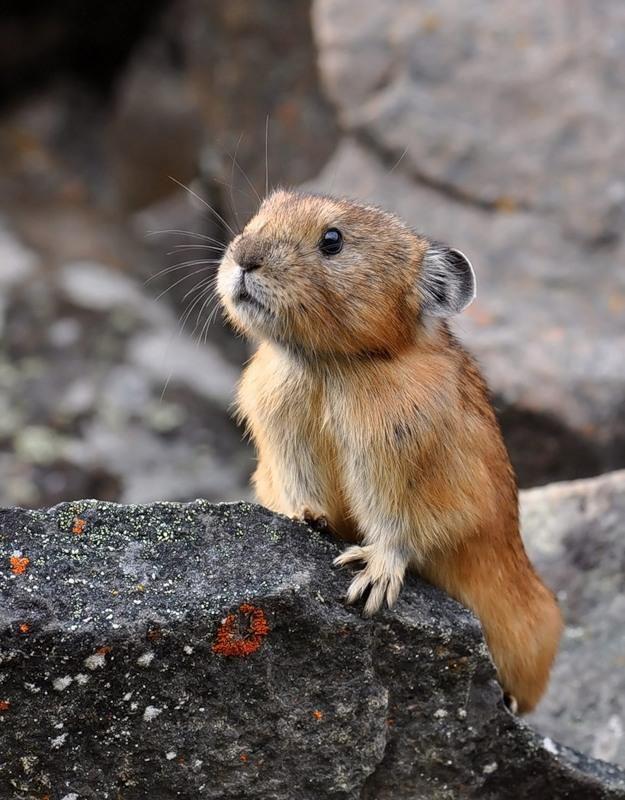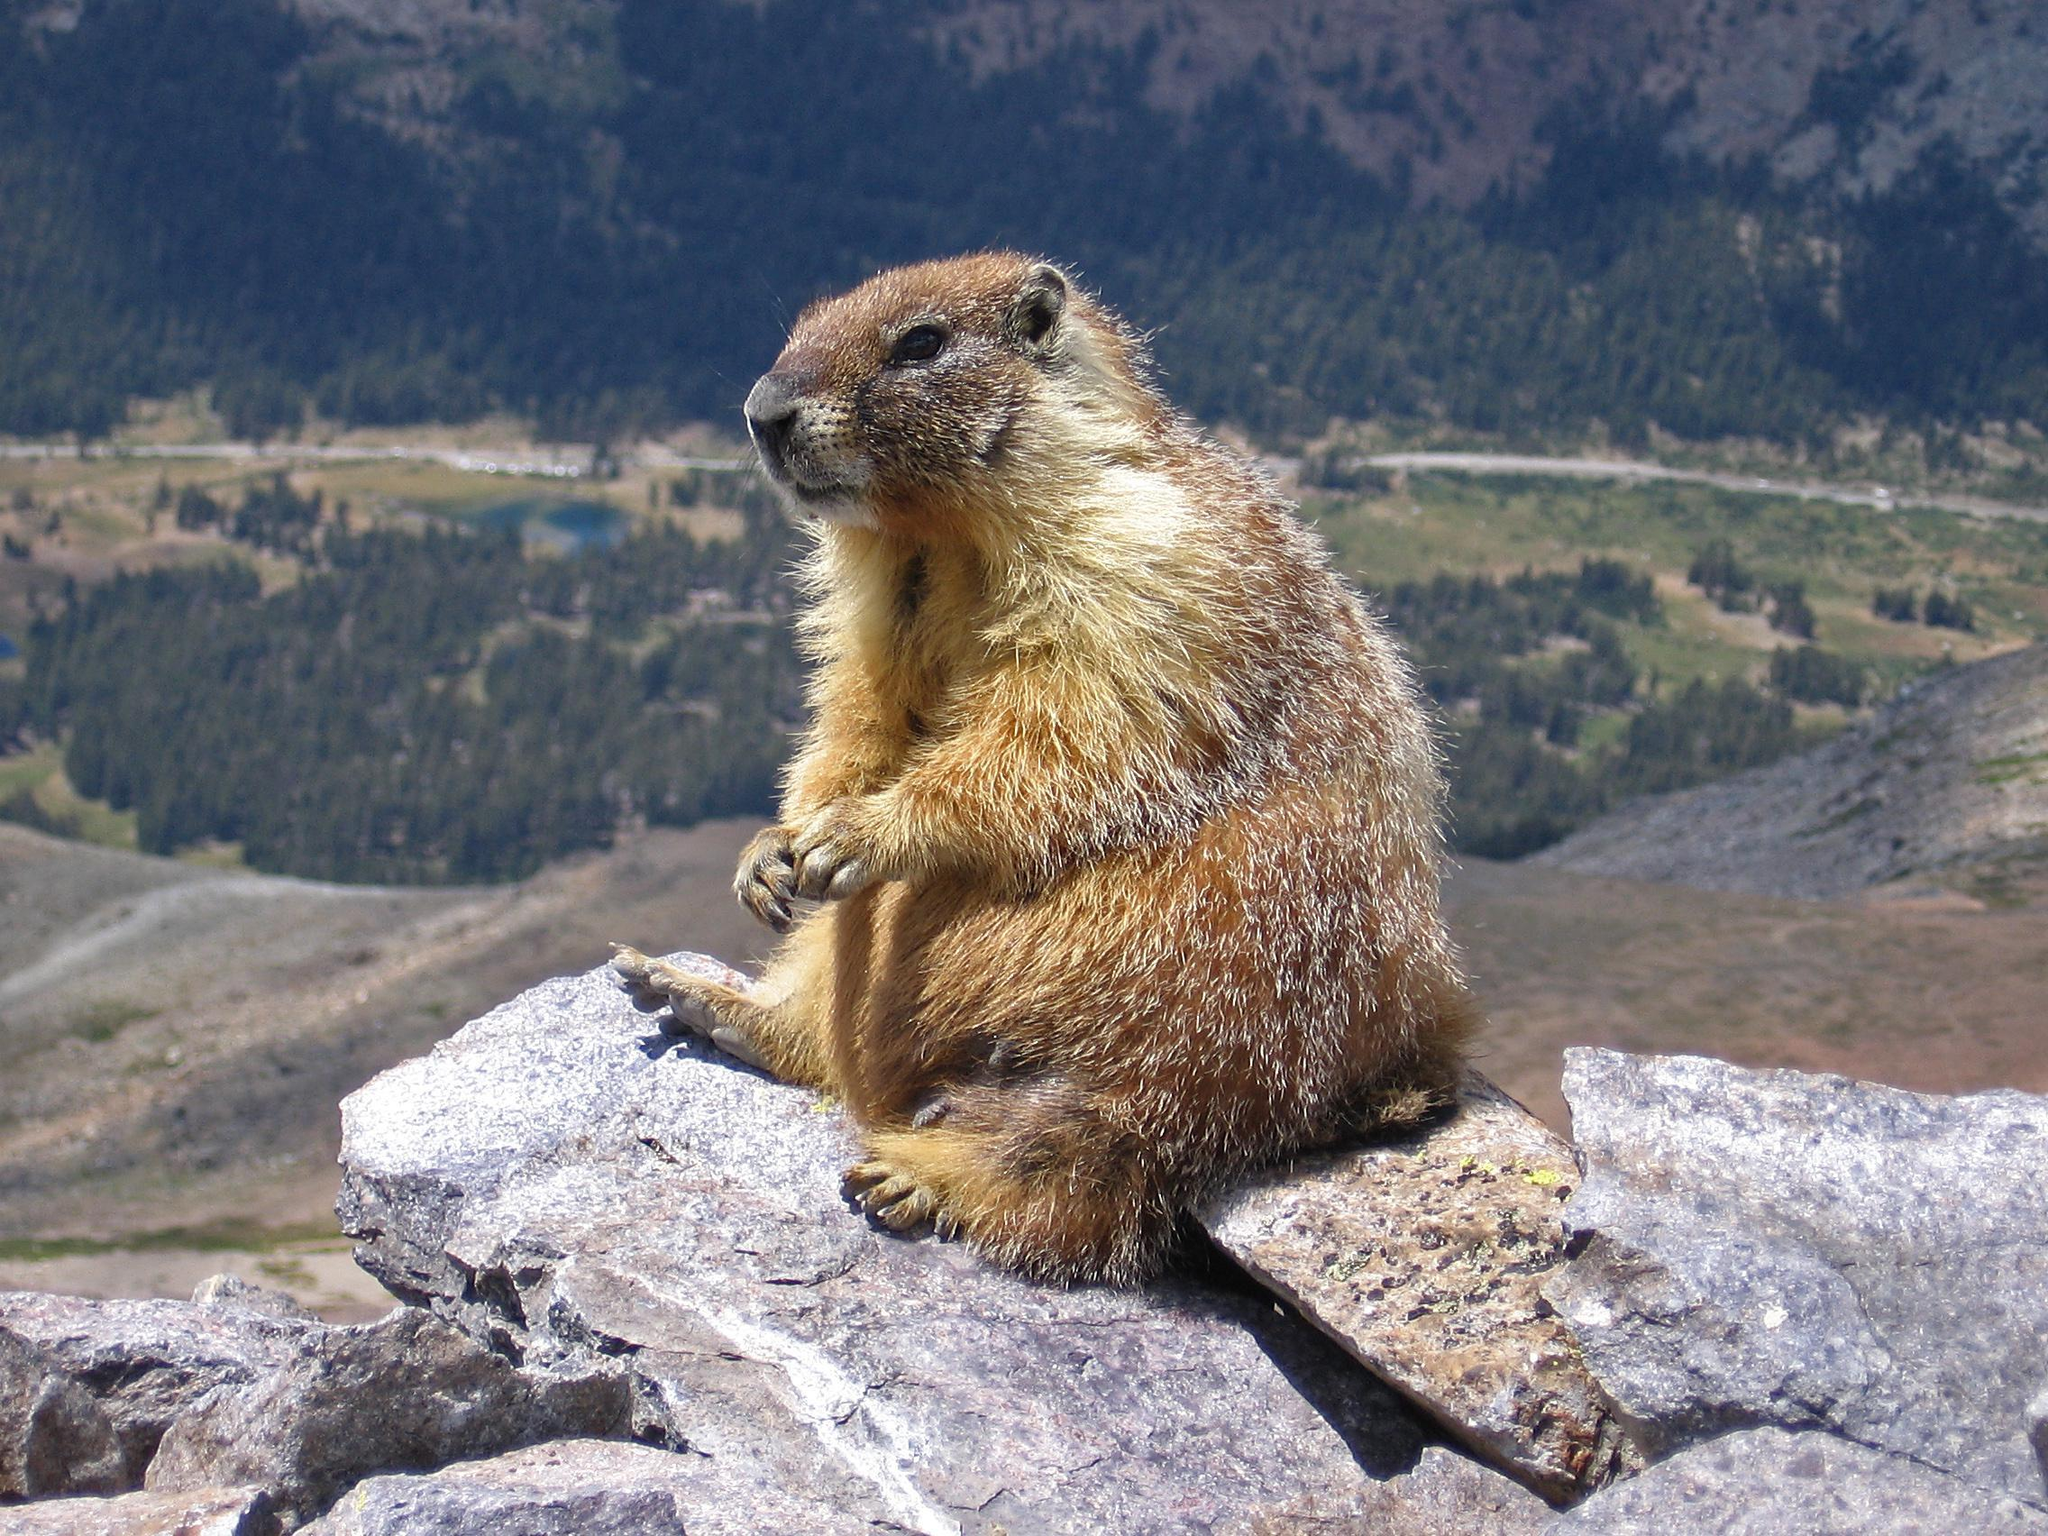The first image is the image on the left, the second image is the image on the right. Evaluate the accuracy of this statement regarding the images: "The right image contains a rodent standing on grass.". Is it true? Answer yes or no. No. The first image is the image on the left, the second image is the image on the right. Analyze the images presented: Is the assertion "A marmot is standing with its front paws raised towards its mouth in a clasping pose." valid? Answer yes or no. No. 